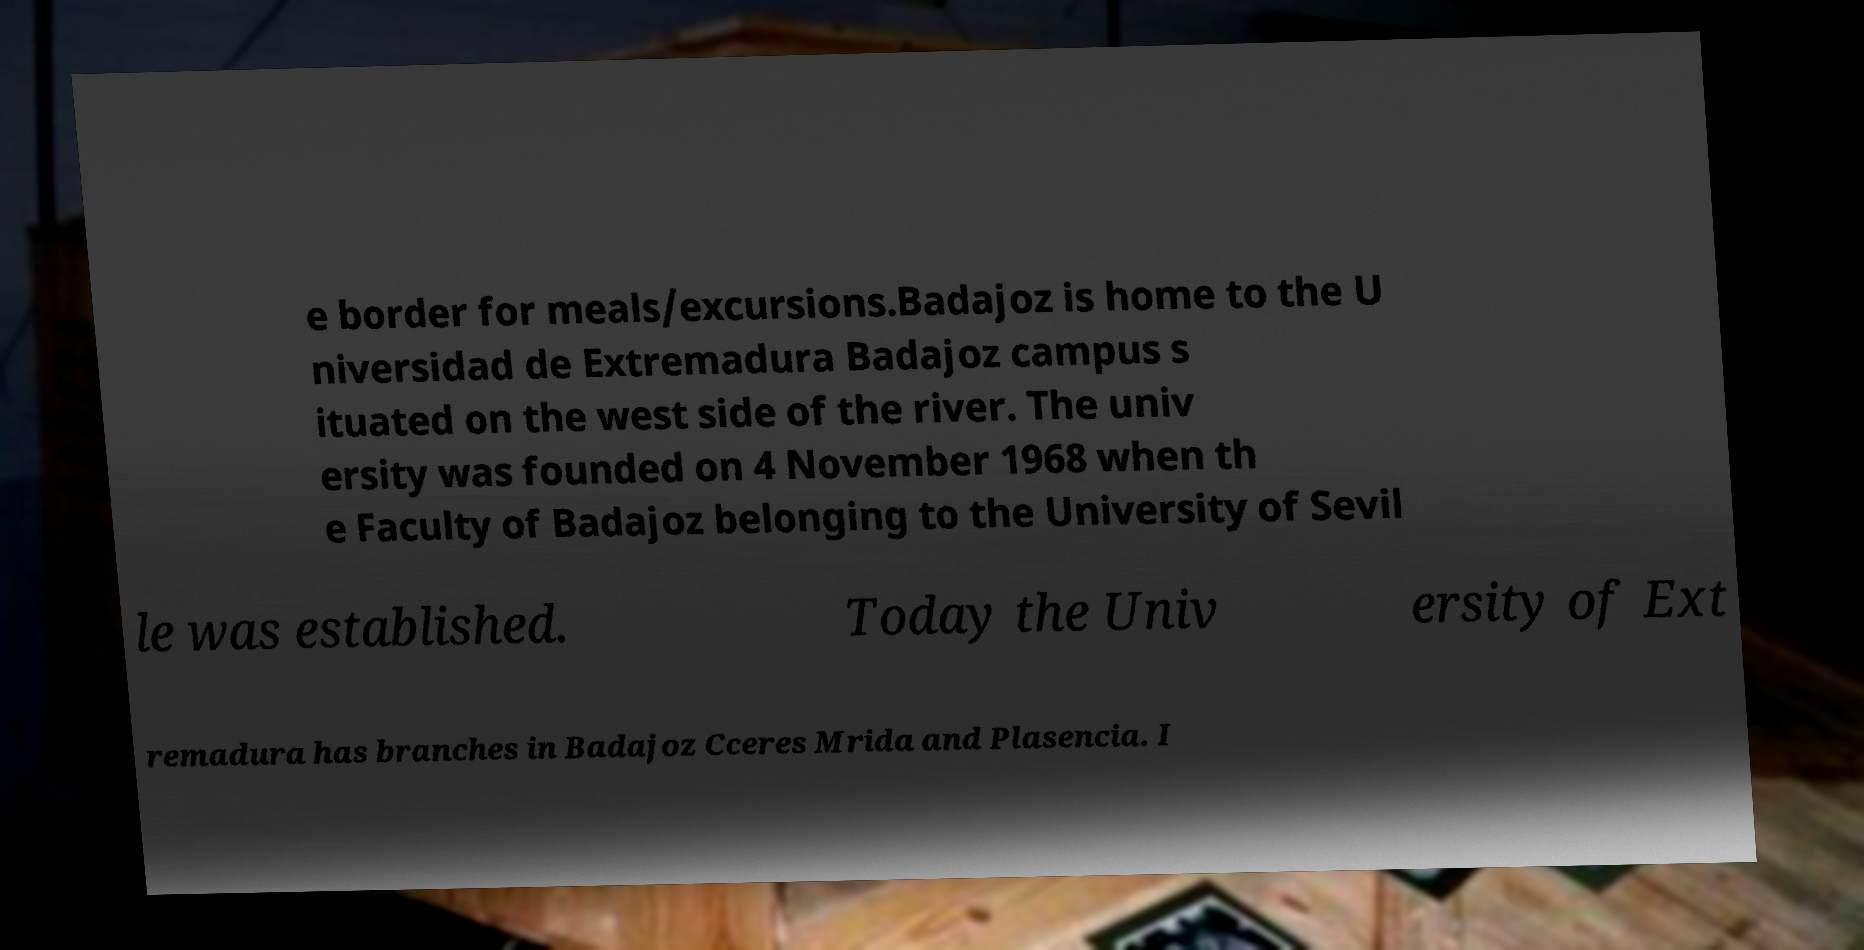Can you read and provide the text displayed in the image?This photo seems to have some interesting text. Can you extract and type it out for me? e border for meals/excursions.Badajoz is home to the U niversidad de Extremadura Badajoz campus s ituated on the west side of the river. The univ ersity was founded on 4 November 1968 when th e Faculty of Badajoz belonging to the University of Sevil le was established. Today the Univ ersity of Ext remadura has branches in Badajoz Cceres Mrida and Plasencia. I 